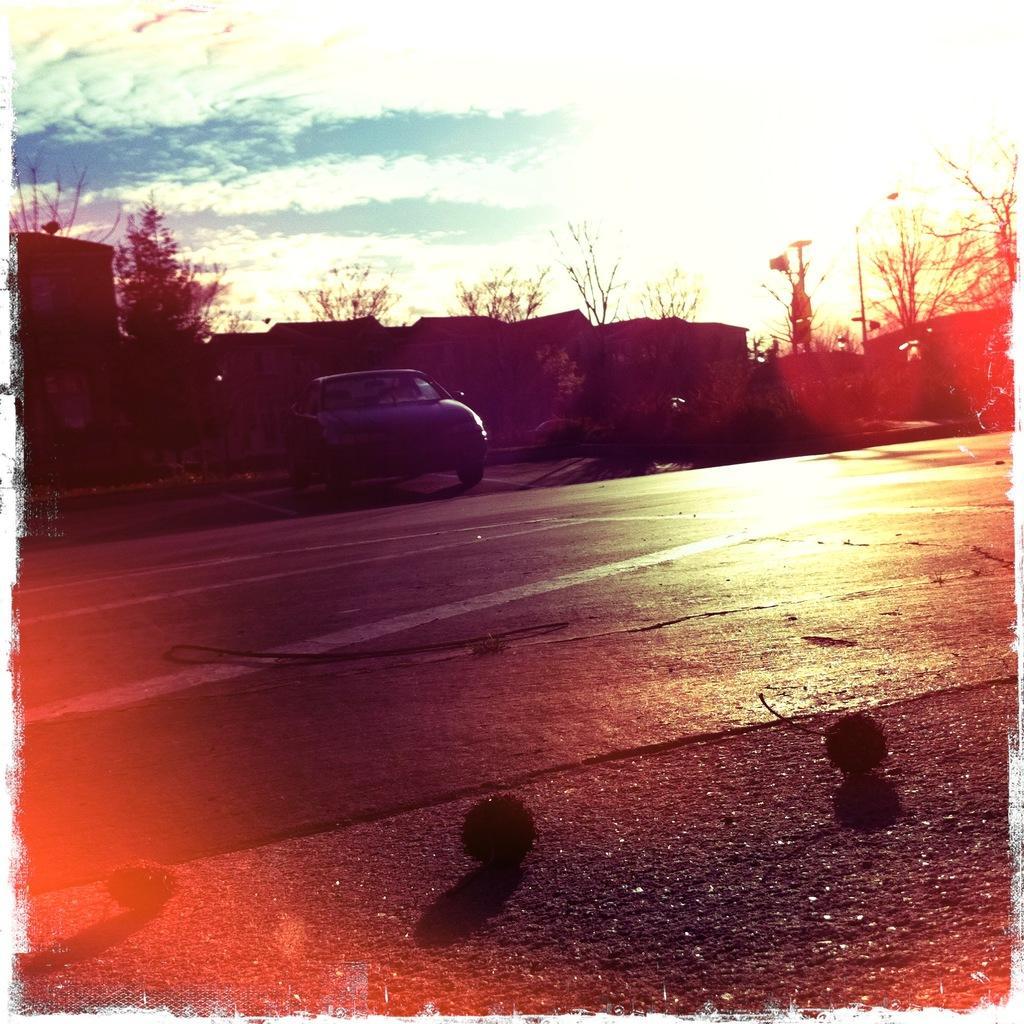Could you give a brief overview of what you see in this image? Here this picture is an edited image, in which we can see a car present on the road and we can also see plants and trees present and we can also see houses present and we can see sun and clouds in the sky. 